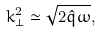<formula> <loc_0><loc_0><loc_500><loc_500>k _ { \perp } ^ { 2 } \simeq \sqrt { 2 \hat { q } \omega } ,</formula> 